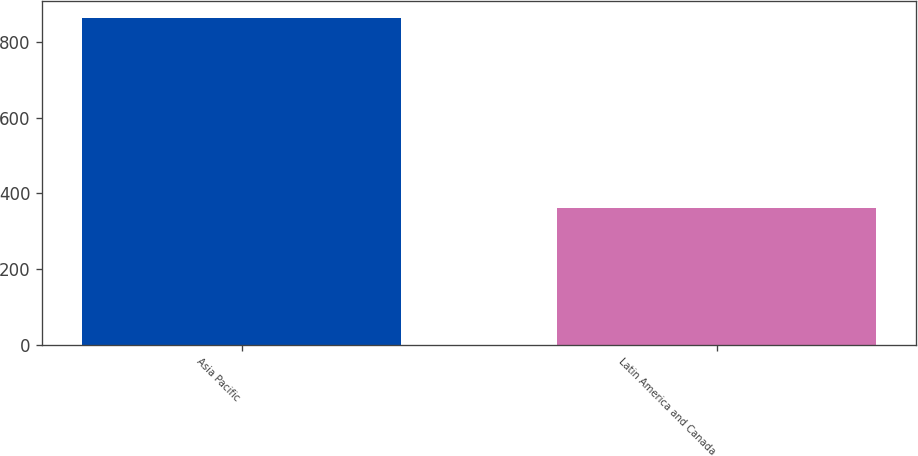<chart> <loc_0><loc_0><loc_500><loc_500><bar_chart><fcel>Asia Pacific<fcel>Latin America and Canada<nl><fcel>865<fcel>361<nl></chart> 